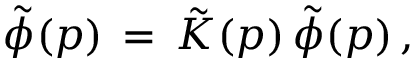Convert formula to latex. <formula><loc_0><loc_0><loc_500><loc_500>\tilde { \phi } ( p ) \, = \, \tilde { K } ( p ) \, \tilde { \phi } ( p ) \, ,</formula> 